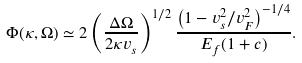Convert formula to latex. <formula><loc_0><loc_0><loc_500><loc_500>\Phi ( \kappa , \Omega ) \simeq 2 \left ( \frac { \Delta \Omega } { 2 \kappa v _ { s } } \right ) ^ { 1 / 2 } \frac { \left ( 1 - { v _ { s } ^ { 2 } } / { v _ { F } ^ { 2 } } \right ) ^ { - 1 / 4 } } { E _ { f } ( 1 + c ) } .</formula> 